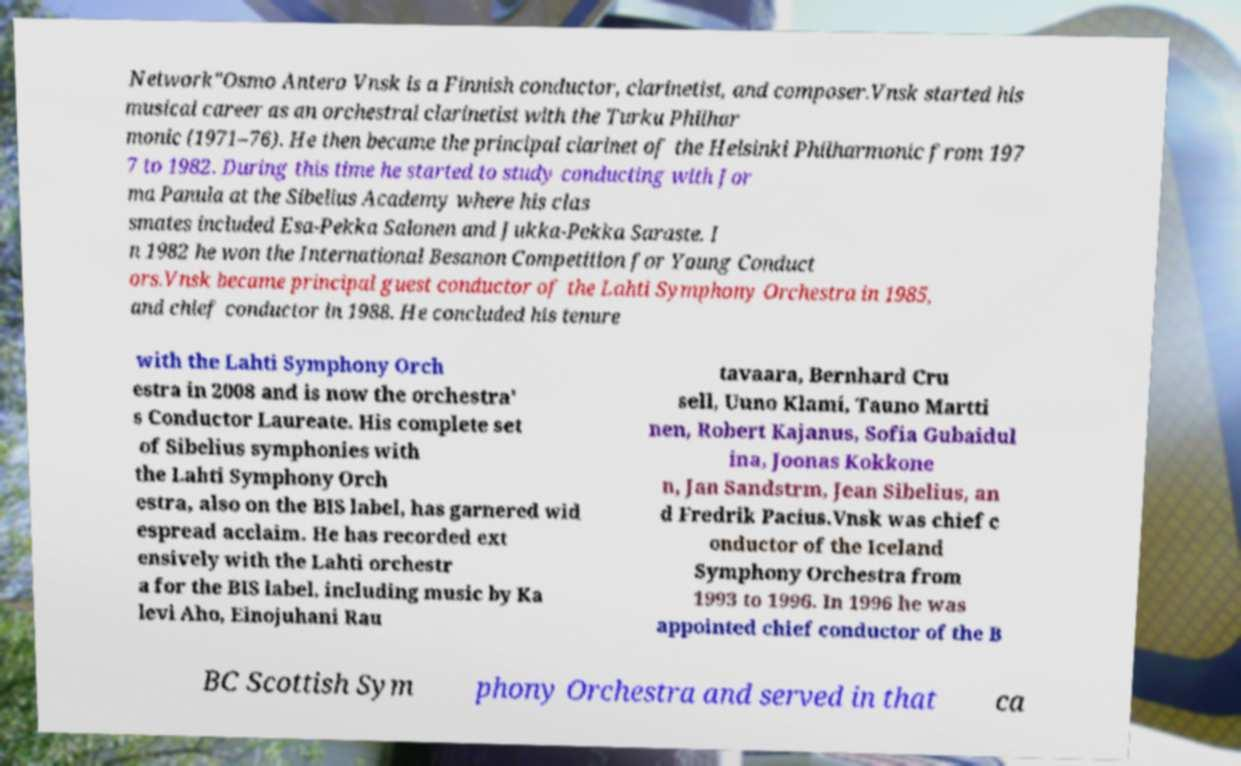I need the written content from this picture converted into text. Can you do that? Network"Osmo Antero Vnsk is a Finnish conductor, clarinetist, and composer.Vnsk started his musical career as an orchestral clarinetist with the Turku Philhar monic (1971–76). He then became the principal clarinet of the Helsinki Philharmonic from 197 7 to 1982. During this time he started to study conducting with Jor ma Panula at the Sibelius Academy where his clas smates included Esa-Pekka Salonen and Jukka-Pekka Saraste. I n 1982 he won the International Besanon Competition for Young Conduct ors.Vnsk became principal guest conductor of the Lahti Symphony Orchestra in 1985, and chief conductor in 1988. He concluded his tenure with the Lahti Symphony Orch estra in 2008 and is now the orchestra' s Conductor Laureate. His complete set of Sibelius symphonies with the Lahti Symphony Orch estra, also on the BIS label, has garnered wid espread acclaim. He has recorded ext ensively with the Lahti orchestr a for the BIS label, including music by Ka levi Aho, Einojuhani Rau tavaara, Bernhard Cru sell, Uuno Klami, Tauno Martti nen, Robert Kajanus, Sofia Gubaidul ina, Joonas Kokkone n, Jan Sandstrm, Jean Sibelius, an d Fredrik Pacius.Vnsk was chief c onductor of the Iceland Symphony Orchestra from 1993 to 1996. In 1996 he was appointed chief conductor of the B BC Scottish Sym phony Orchestra and served in that ca 